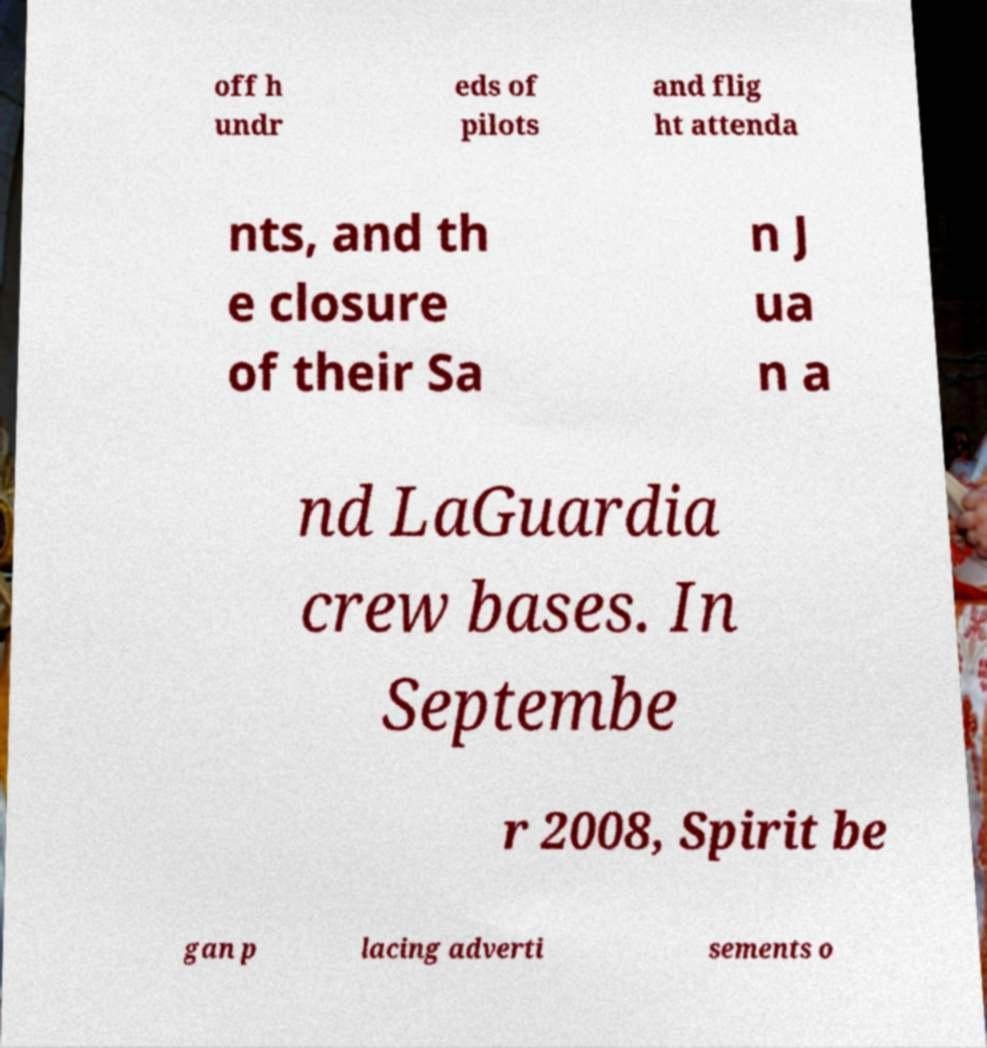Please identify and transcribe the text found in this image. off h undr eds of pilots and flig ht attenda nts, and th e closure of their Sa n J ua n a nd LaGuardia crew bases. In Septembe r 2008, Spirit be gan p lacing adverti sements o 